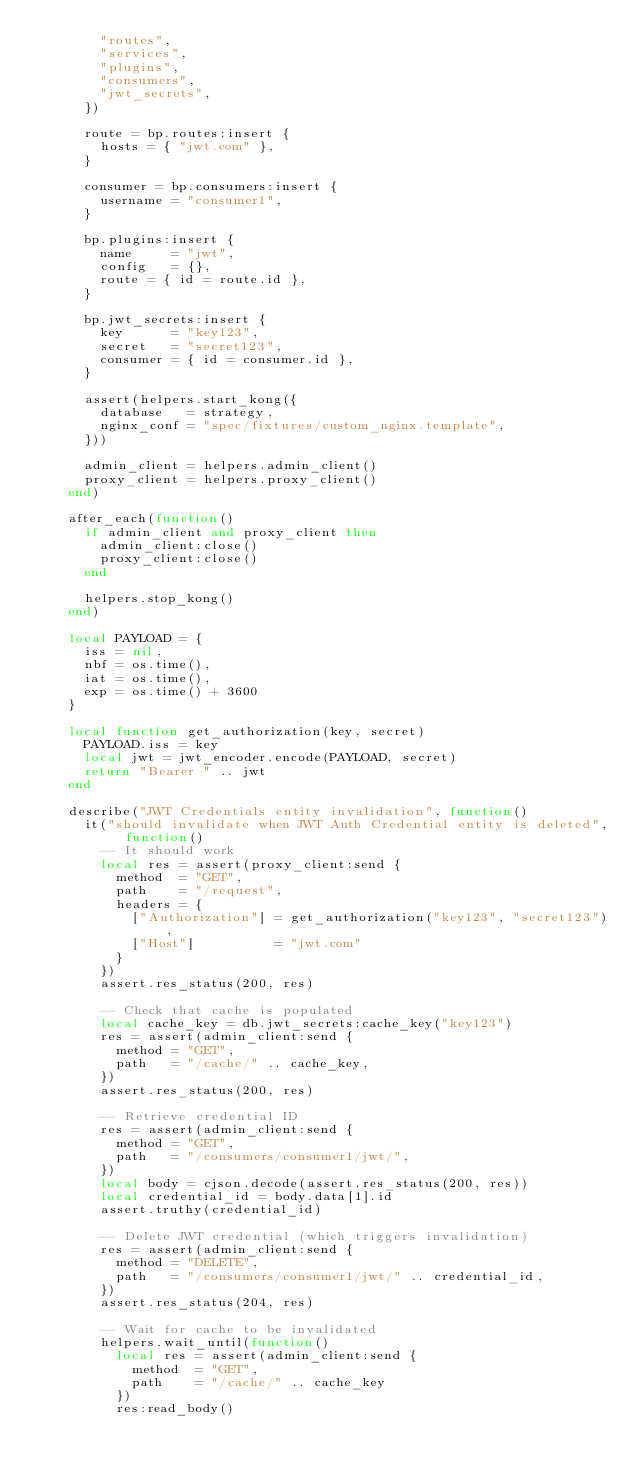<code> <loc_0><loc_0><loc_500><loc_500><_Lua_>        "routes",
        "services",
        "plugins",
        "consumers",
        "jwt_secrets",
      })

      route = bp.routes:insert {
        hosts = { "jwt.com" },
      }

      consumer = bp.consumers:insert {
        username = "consumer1",
      }

      bp.plugins:insert {
        name     = "jwt",
        config   = {},
        route = { id = route.id },
      }

      bp.jwt_secrets:insert {
        key      = "key123",
        secret   = "secret123",
        consumer = { id = consumer.id },
      }

      assert(helpers.start_kong({
        database   = strategy,
        nginx_conf = "spec/fixtures/custom_nginx.template",
      }))

      admin_client = helpers.admin_client()
      proxy_client = helpers.proxy_client()
    end)

    after_each(function()
      if admin_client and proxy_client then
        admin_client:close()
        proxy_client:close()
      end

      helpers.stop_kong()
    end)

    local PAYLOAD = {
      iss = nil,
      nbf = os.time(),
      iat = os.time(),
      exp = os.time() + 3600
    }

    local function get_authorization(key, secret)
      PAYLOAD.iss = key
      local jwt = jwt_encoder.encode(PAYLOAD, secret)
      return "Bearer " .. jwt
    end

    describe("JWT Credentials entity invalidation", function()
      it("should invalidate when JWT Auth Credential entity is deleted", function()
        -- It should work
        local res = assert(proxy_client:send {
          method  = "GET",
          path    = "/request",
          headers = {
            ["Authorization"] = get_authorization("key123", "secret123"),
            ["Host"]          = "jwt.com"
          }
        })
        assert.res_status(200, res)

        -- Check that cache is populated
        local cache_key = db.jwt_secrets:cache_key("key123")
        res = assert(admin_client:send {
          method = "GET",
          path   = "/cache/" .. cache_key,
        })
        assert.res_status(200, res)

        -- Retrieve credential ID
        res = assert(admin_client:send {
          method = "GET",
          path   = "/consumers/consumer1/jwt/",
        })
        local body = cjson.decode(assert.res_status(200, res))
        local credential_id = body.data[1].id
        assert.truthy(credential_id)

        -- Delete JWT credential (which triggers invalidation)
        res = assert(admin_client:send {
          method = "DELETE",
          path   = "/consumers/consumer1/jwt/" .. credential_id,
        })
        assert.res_status(204, res)

        -- Wait for cache to be invalidated
        helpers.wait_until(function()
          local res = assert(admin_client:send {
            method  = "GET",
            path    = "/cache/" .. cache_key
          })
          res:read_body()</code> 